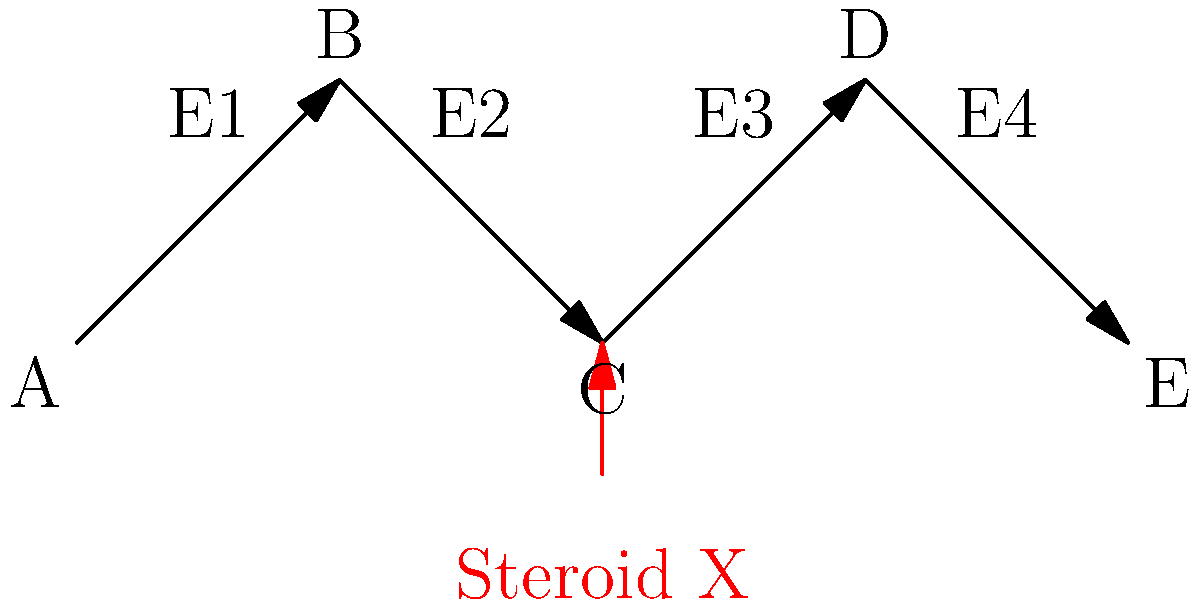In the metabolic pathway diagram above, a performance-enhancing steroid X inhibits enzyme E3. If an athlete uses this steroid, which metabolite(s) would you expect to accumulate in their system? Explain your reasoning based on the pathway. To answer this question, we need to analyze the metabolic pathway and the effect of the inhibitor:

1. The pathway shows a series of reactions: A → B → C → D → E
2. Each step is catalyzed by a specific enzyme (E1, E2, E3, E4)
3. Steroid X inhibits enzyme E3, which catalyzes the conversion of C to D

Given this information, we can reason as follows:

1. Inhibition of E3 will slow down or stop the conversion of C to D
2. As C cannot be efficiently converted to D, it will start to accumulate in the system
3. The accumulation of C may also lead to a slight increase in B, as the equilibrium of the B to C reaction (catalyzed by E2) may shift
4. The levels of D and E will likely decrease, as their production is dependent on the activity of E3

Therefore, we can conclude that metabolite C would primarily accumulate in the athlete's system, with a possible slight increase in B as well.
Answer: Metabolite C (primary), possibly B (secondary) 